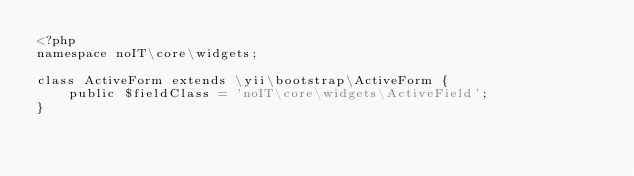Convert code to text. <code><loc_0><loc_0><loc_500><loc_500><_PHP_><?php
namespace noIT\core\widgets;

class ActiveForm extends \yii\bootstrap\ActiveForm {
    public $fieldClass = 'noIT\core\widgets\ActiveField';
}</code> 